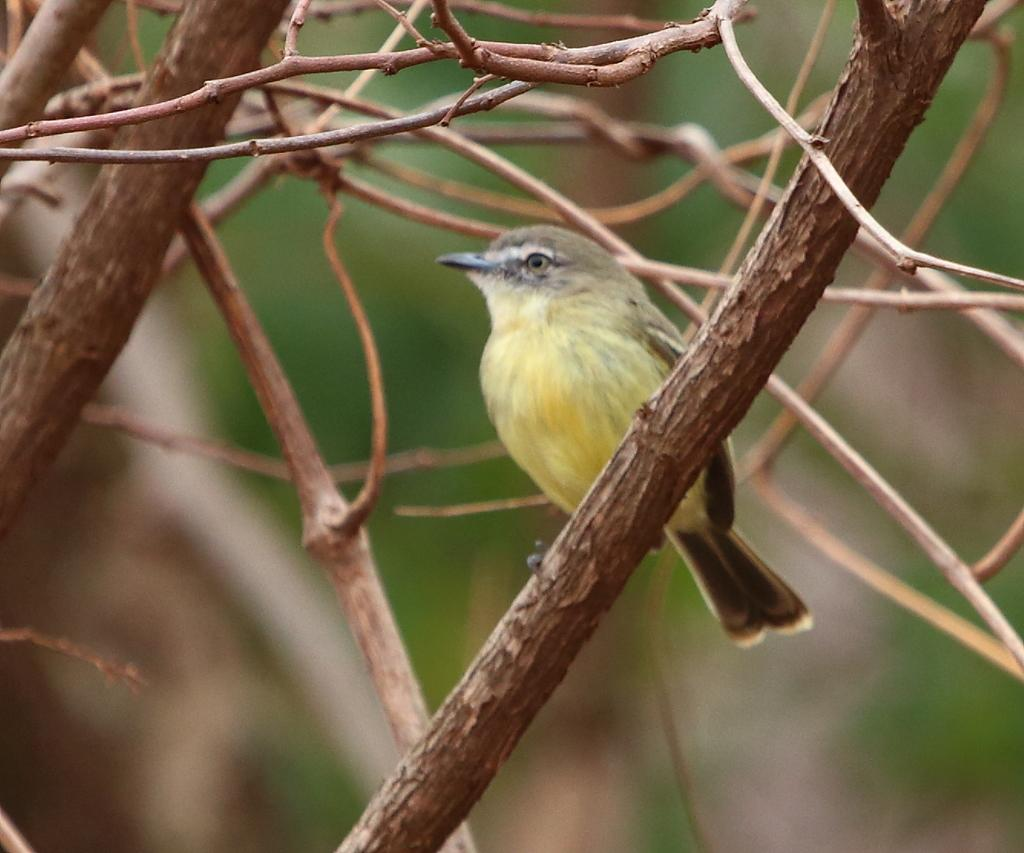What type of animal can be seen in the image? There is a bird in the image. Where is the bird located in the image? The bird is in the branches. Are there any cemeteries visible in the image? There is no mention of a cemetery in the provided facts, and therefore it cannot be determined if one is present in the image. 